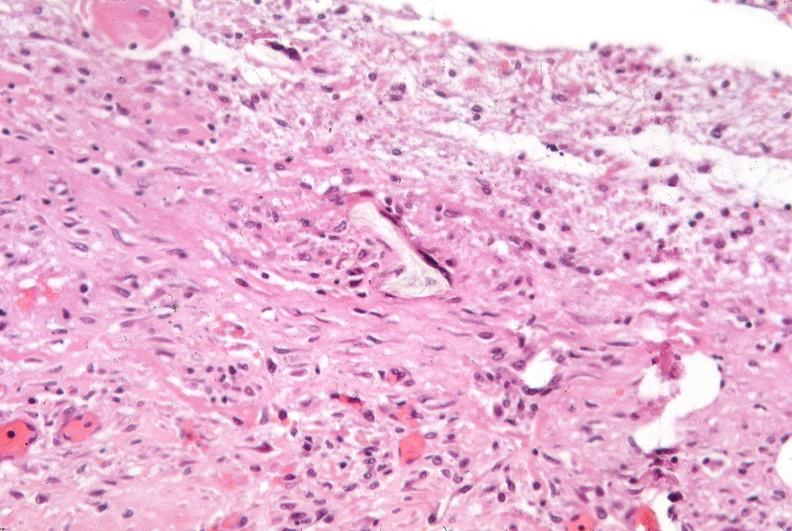how many antitrypsin was talc used to sclerose emphysematous lung, alpha-deficiency?
Answer the question using a single word or phrase. 1 